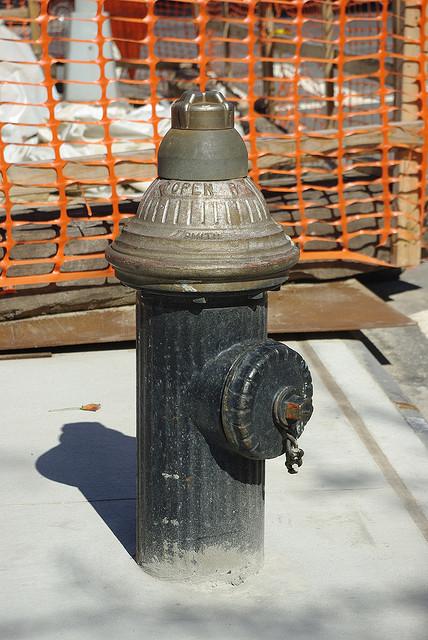Is the shadow of the hydrant visible?
Write a very short answer. Yes. What is the object in orange?
Write a very short answer. Fence. What color is the fire hydrant?
Write a very short answer. Black. 